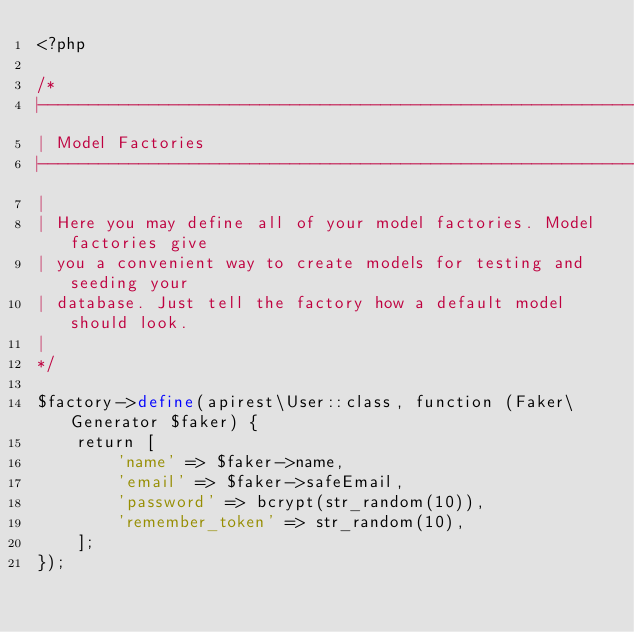<code> <loc_0><loc_0><loc_500><loc_500><_PHP_><?php

/*
|--------------------------------------------------------------------------
| Model Factories
|--------------------------------------------------------------------------
|
| Here you may define all of your model factories. Model factories give
| you a convenient way to create models for testing and seeding your
| database. Just tell the factory how a default model should look.
|
*/

$factory->define(apirest\User::class, function (Faker\Generator $faker) {
    return [
        'name' => $faker->name,
        'email' => $faker->safeEmail,
        'password' => bcrypt(str_random(10)),
        'remember_token' => str_random(10),
    ];
});
</code> 